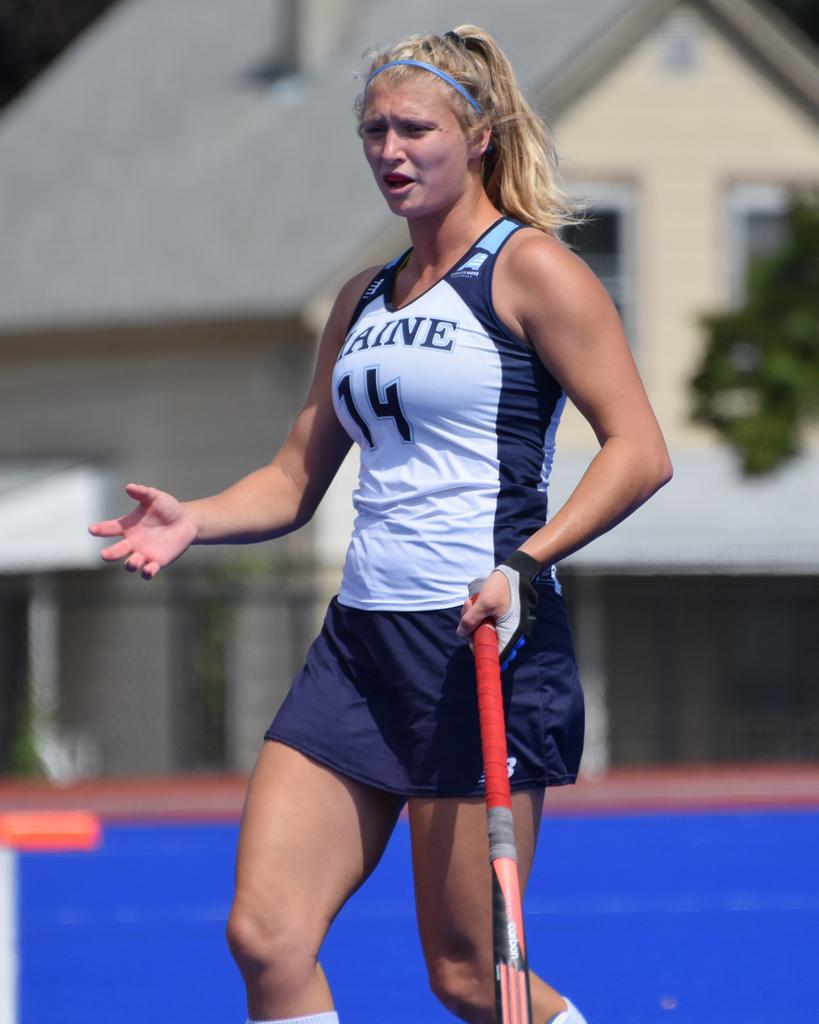<image>
Summarize the visual content of the image. A woman athlete holding a field hockey stick with the number 14 on her uniform. 